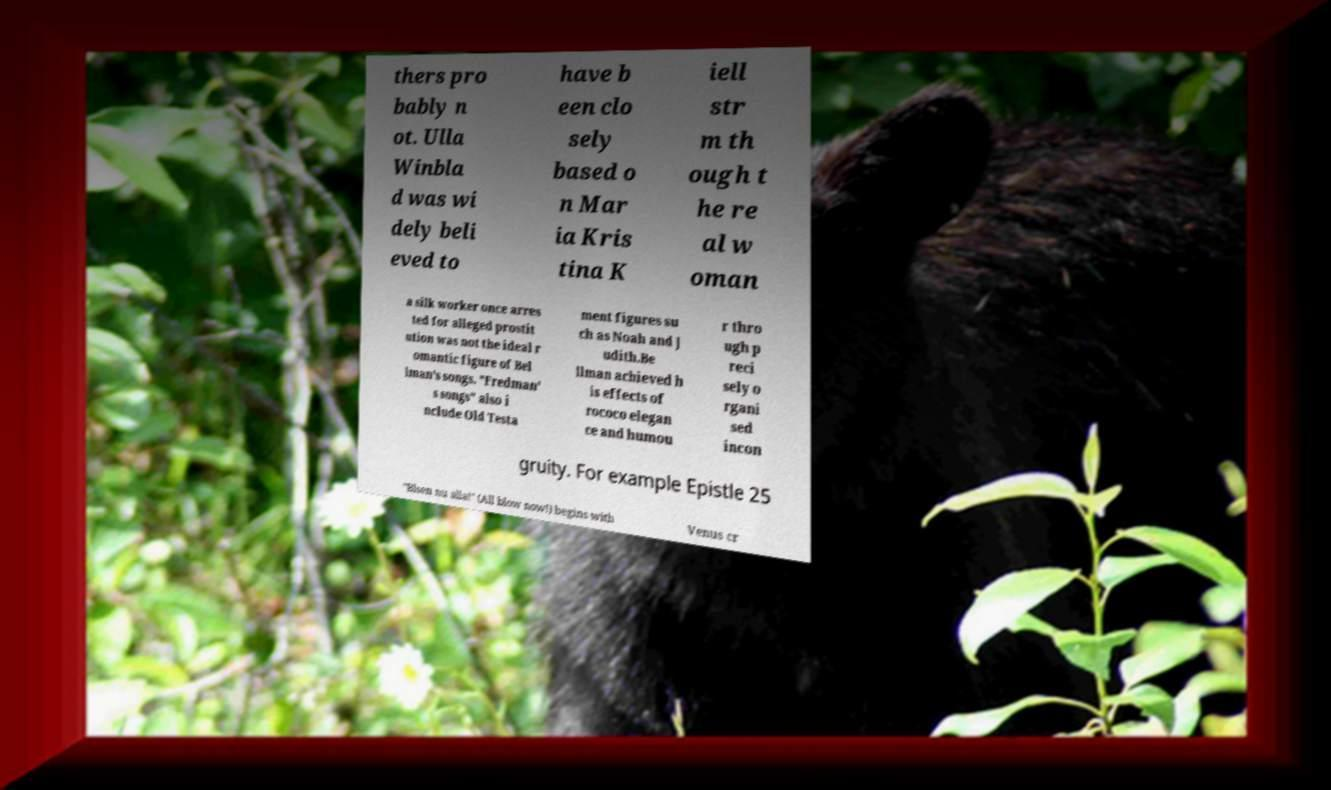Please read and relay the text visible in this image. What does it say? thers pro bably n ot. Ulla Winbla d was wi dely beli eved to have b een clo sely based o n Mar ia Kris tina K iell str m th ough t he re al w oman a silk worker once arres ted for alleged prostit ution was not the ideal r omantic figure of Bel lman's songs. "Fredman' s songs" also i nclude Old Testa ment figures su ch as Noah and J udith.Be llman achieved h is effects of rococo elegan ce and humou r thro ugh p reci sely o rgani sed incon gruity. For example Epistle 25 "Blsen nu alla!" (All blow now!) begins with Venus cr 